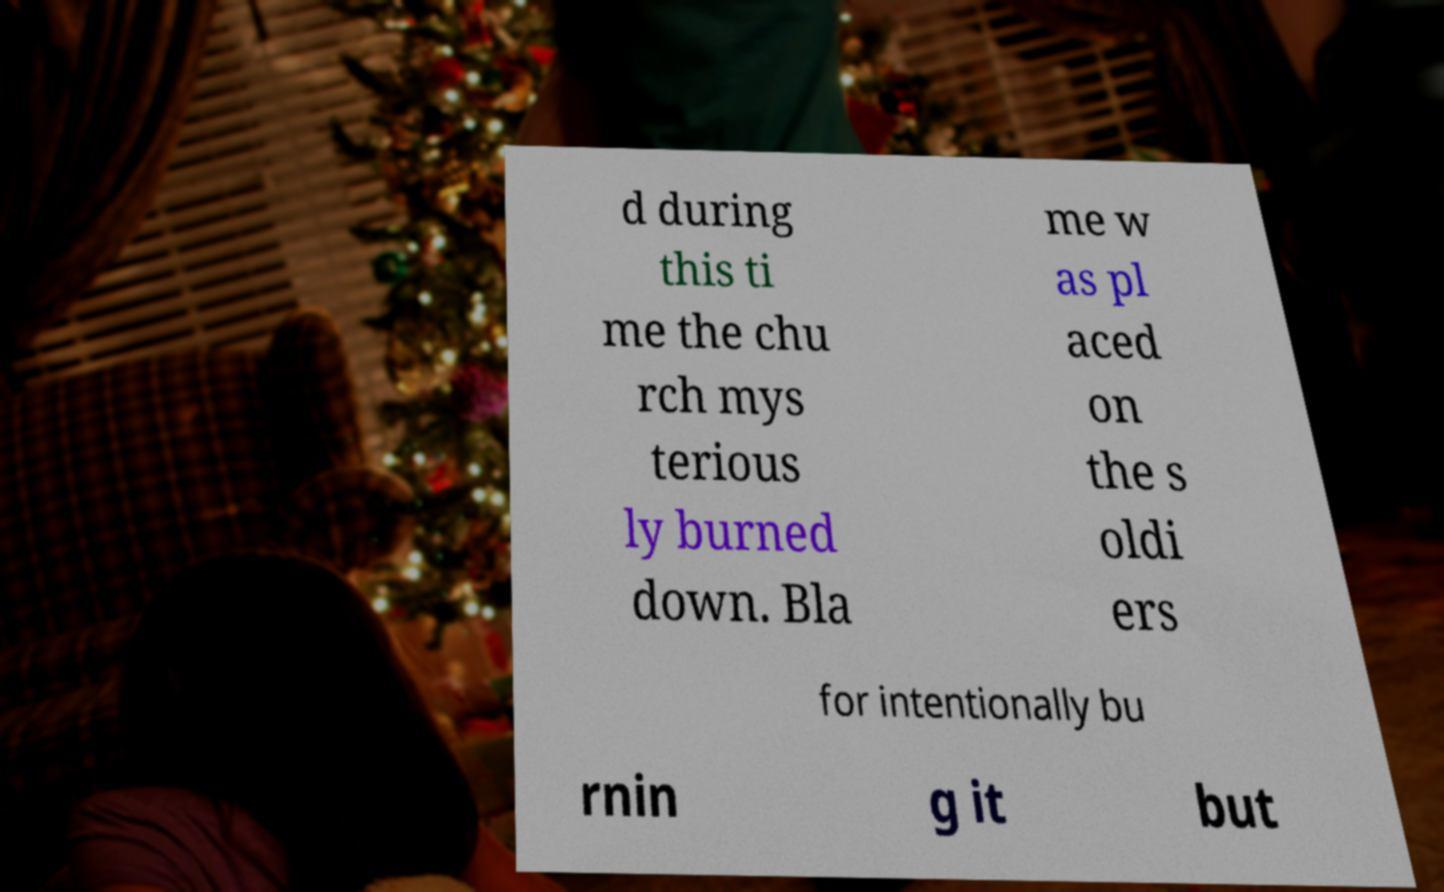Can you accurately transcribe the text from the provided image for me? d during this ti me the chu rch mys terious ly burned down. Bla me w as pl aced on the s oldi ers for intentionally bu rnin g it but 